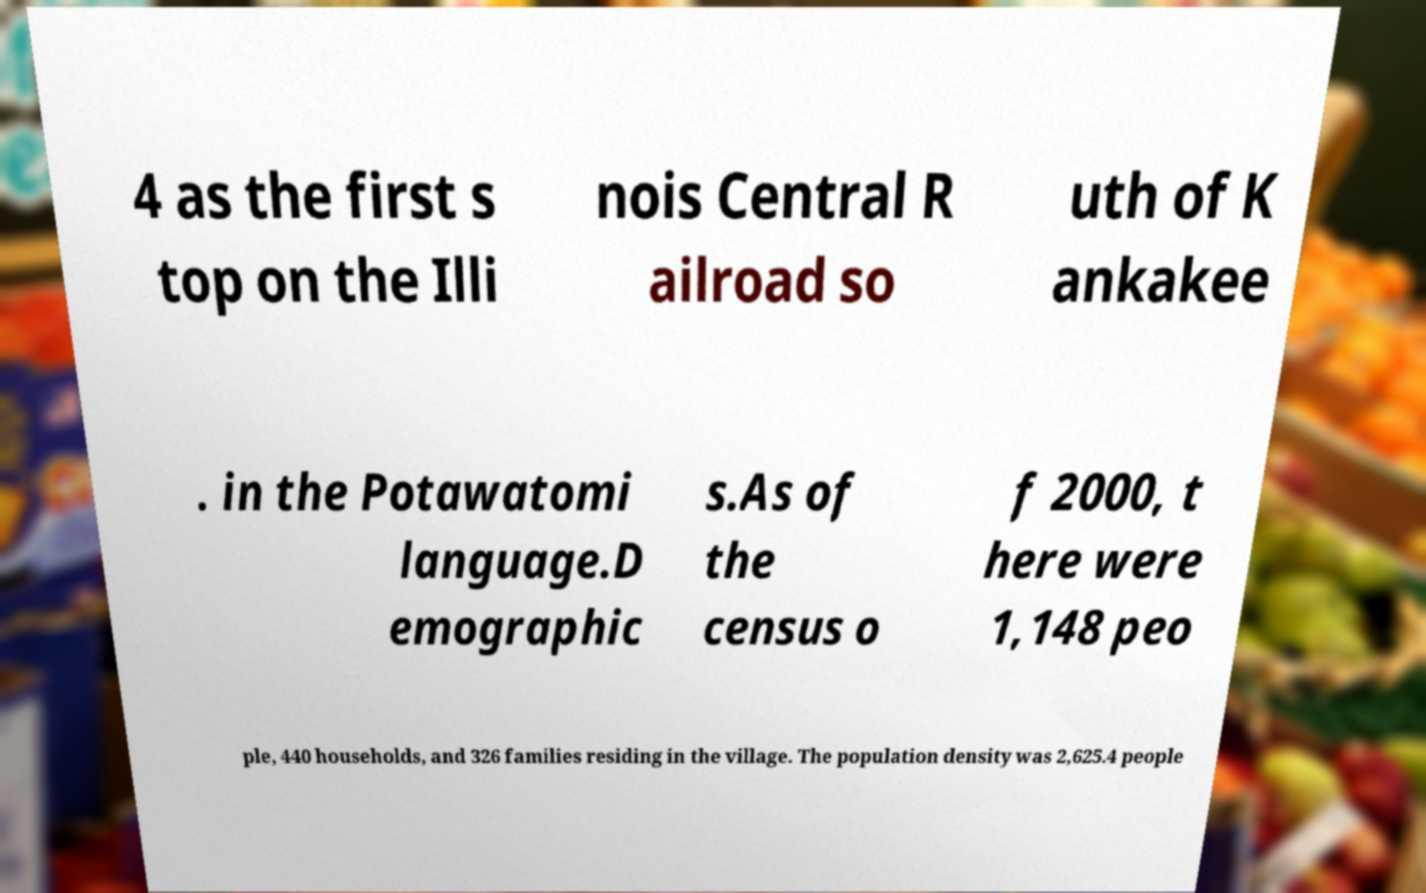For documentation purposes, I need the text within this image transcribed. Could you provide that? 4 as the first s top on the Illi nois Central R ailroad so uth of K ankakee . in the Potawatomi language.D emographic s.As of the census o f 2000, t here were 1,148 peo ple, 440 households, and 326 families residing in the village. The population density was 2,625.4 people 